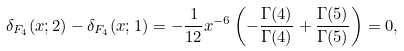Convert formula to latex. <formula><loc_0><loc_0><loc_500><loc_500>\delta _ { F _ { 4 } } ( x ; 2 ) - \delta _ { F _ { 4 } } ( x ; 1 ) = - { \frac { 1 } { 1 2 } } x ^ { - 6 } \left ( - { \frac { \Gamma ( 4 ) } { \Gamma ( 4 ) } } + { \frac { \Gamma ( 5 ) } { \Gamma ( 5 ) } } \right ) = 0 ,</formula> 